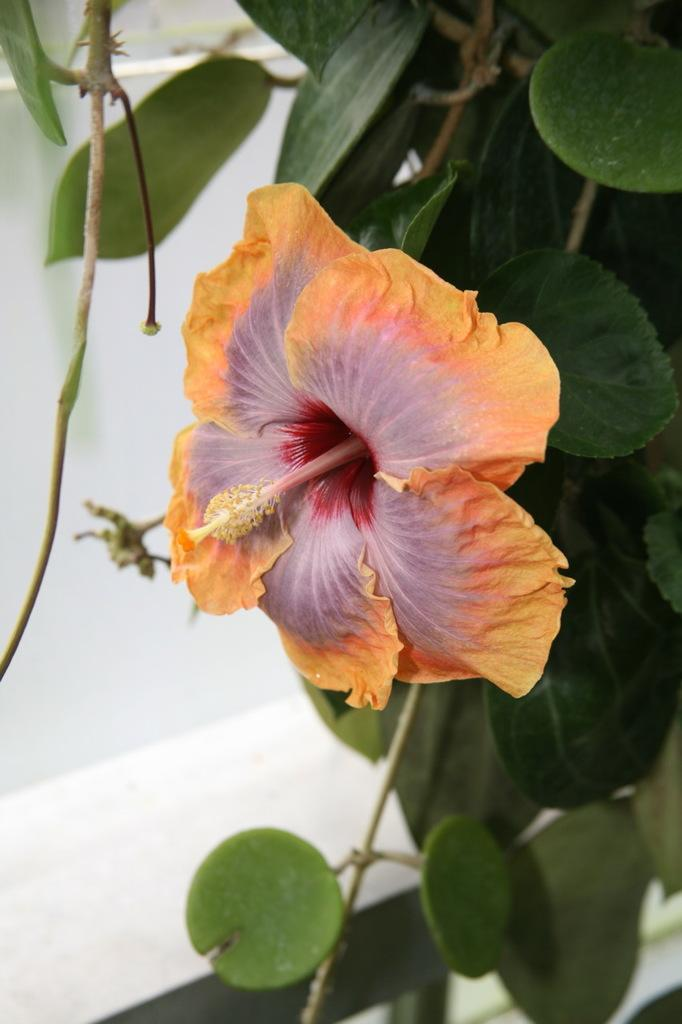What is present in the image? There is a plant in the image. What type of flower is on the plant? The plant has a hibiscus flower. What color is the background of the image? The background of the image is white. Where is the hen located in the image? There is no hen present in the image. How many trucks can be seen in the image? There are no trucks present in the image. 